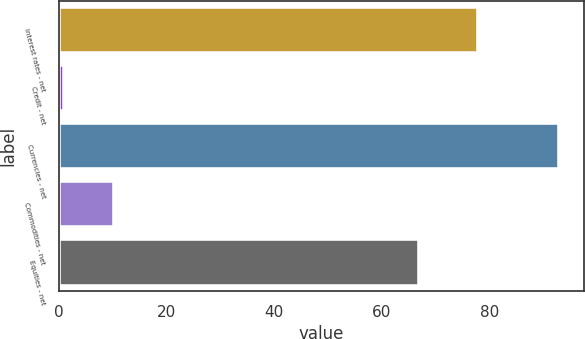Convert chart. <chart><loc_0><loc_0><loc_500><loc_500><bar_chart><fcel>Interest rates - net<fcel>Credit - net<fcel>Currencies - net<fcel>Commodities - net<fcel>Equities - net<nl><fcel>78<fcel>1<fcel>93<fcel>10.2<fcel>67<nl></chart> 